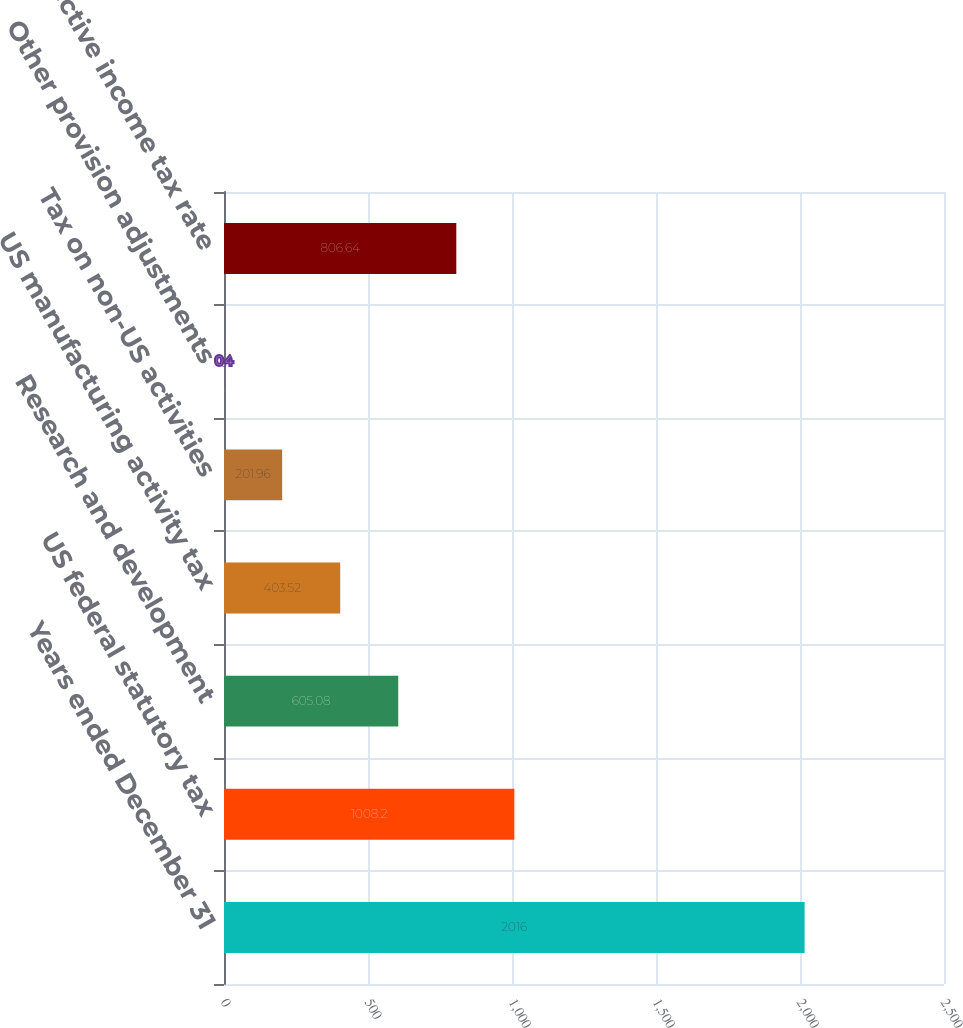Convert chart to OTSL. <chart><loc_0><loc_0><loc_500><loc_500><bar_chart><fcel>Years ended December 31<fcel>US federal statutory tax<fcel>Research and development<fcel>US manufacturing activity tax<fcel>Tax on non-US activities<fcel>Other provision adjustments<fcel>Effective income tax rate<nl><fcel>2016<fcel>1008.2<fcel>605.08<fcel>403.52<fcel>201.96<fcel>0.4<fcel>806.64<nl></chart> 